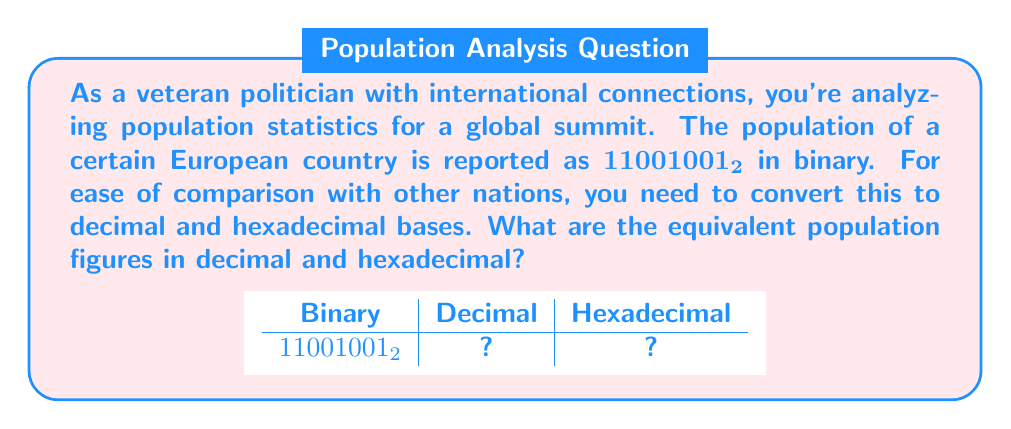Teach me how to tackle this problem. Let's approach this step-by-step:

1) First, we'll convert the binary number to decimal:

   $11001001_2 = 1\cdot2^7 + 1\cdot2^6 + 0\cdot2^5 + 0\cdot2^4 + 1\cdot2^3 + 0\cdot2^2 + 0\cdot2^1 + 1\cdot2^0$

   $= 128 + 64 + 0 + 0 + 8 + 0 + 0 + 1$
   
   $= 201_{10}$

2) Now that we have the decimal representation, we can convert it to hexadecimal:

   To convert to hexadecimal, we divide the decimal number by 16 repeatedly and keep track of the remainders:

   $201 \div 16 = 12$ remainder $9$
   $12 \div 16 = 0$ remainder $12$

   Reading the remainders from bottom to top, we get:

   $12_{10} = C_{16}$ and $9_{10} = 9_{16}$

   Therefore, $201_{10} = C9_{16}$

Thus, the population in decimal is 201, and in hexadecimal is C9.
Answer: $201_{10}$, $C9_{16}$ 